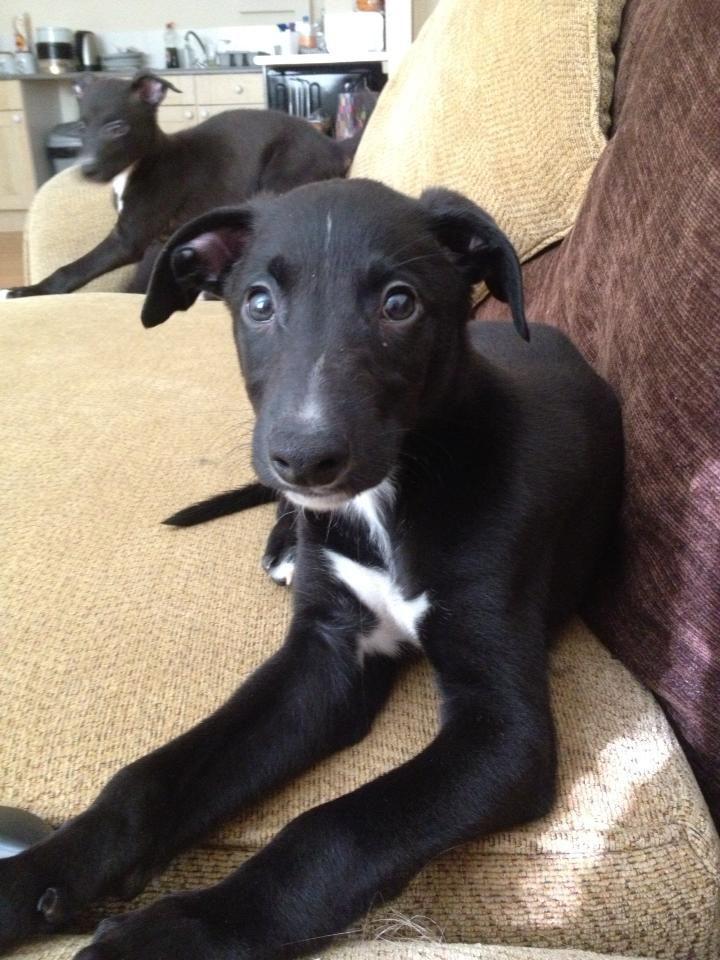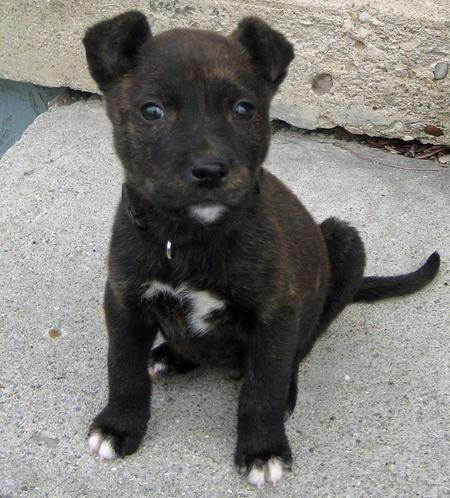The first image is the image on the left, the second image is the image on the right. Given the left and right images, does the statement "Two dogs are looking straight ahead." hold true? Answer yes or no. Yes. The first image is the image on the left, the second image is the image on the right. For the images shown, is this caption "There is at least 1 young puppy with it's ears pulled back." true? Answer yes or no. No. 